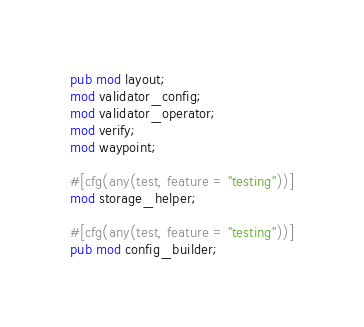<code> <loc_0><loc_0><loc_500><loc_500><_Rust_>pub mod layout;
mod validator_config;
mod validator_operator;
mod verify;
mod waypoint;

#[cfg(any(test, feature = "testing"))]
mod storage_helper;

#[cfg(any(test, feature = "testing"))]
pub mod config_builder;
</code> 